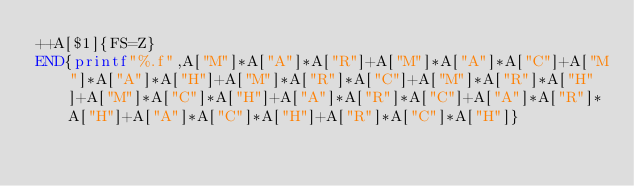Convert code to text. <code><loc_0><loc_0><loc_500><loc_500><_Awk_>++A[$1]{FS=Z}
END{printf"%.f",A["M"]*A["A"]*A["R"]+A["M"]*A["A"]*A["C"]+A["M"]*A["A"]*A["H"]+A["M"]*A["R"]*A["C"]+A["M"]*A["R"]*A["H"]+A["M"]*A["C"]*A["H"]+A["A"]*A["R"]*A["C"]+A["A"]*A["R"]*A["H"]+A["A"]*A["C"]*A["H"]+A["R"]*A["C"]*A["H"]}</code> 